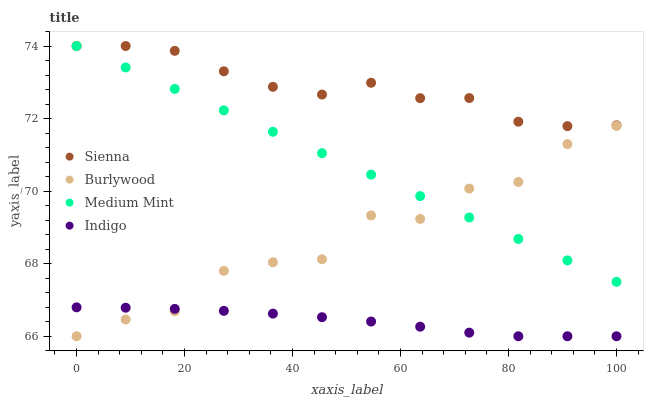Does Indigo have the minimum area under the curve?
Answer yes or no. Yes. Does Sienna have the maximum area under the curve?
Answer yes or no. Yes. Does Burlywood have the minimum area under the curve?
Answer yes or no. No. Does Burlywood have the maximum area under the curve?
Answer yes or no. No. Is Medium Mint the smoothest?
Answer yes or no. Yes. Is Burlywood the roughest?
Answer yes or no. Yes. Is Indigo the smoothest?
Answer yes or no. No. Is Indigo the roughest?
Answer yes or no. No. Does Burlywood have the lowest value?
Answer yes or no. Yes. Does Medium Mint have the lowest value?
Answer yes or no. No. Does Medium Mint have the highest value?
Answer yes or no. Yes. Does Burlywood have the highest value?
Answer yes or no. No. Is Burlywood less than Sienna?
Answer yes or no. Yes. Is Sienna greater than Burlywood?
Answer yes or no. Yes. Does Burlywood intersect Medium Mint?
Answer yes or no. Yes. Is Burlywood less than Medium Mint?
Answer yes or no. No. Is Burlywood greater than Medium Mint?
Answer yes or no. No. Does Burlywood intersect Sienna?
Answer yes or no. No. 